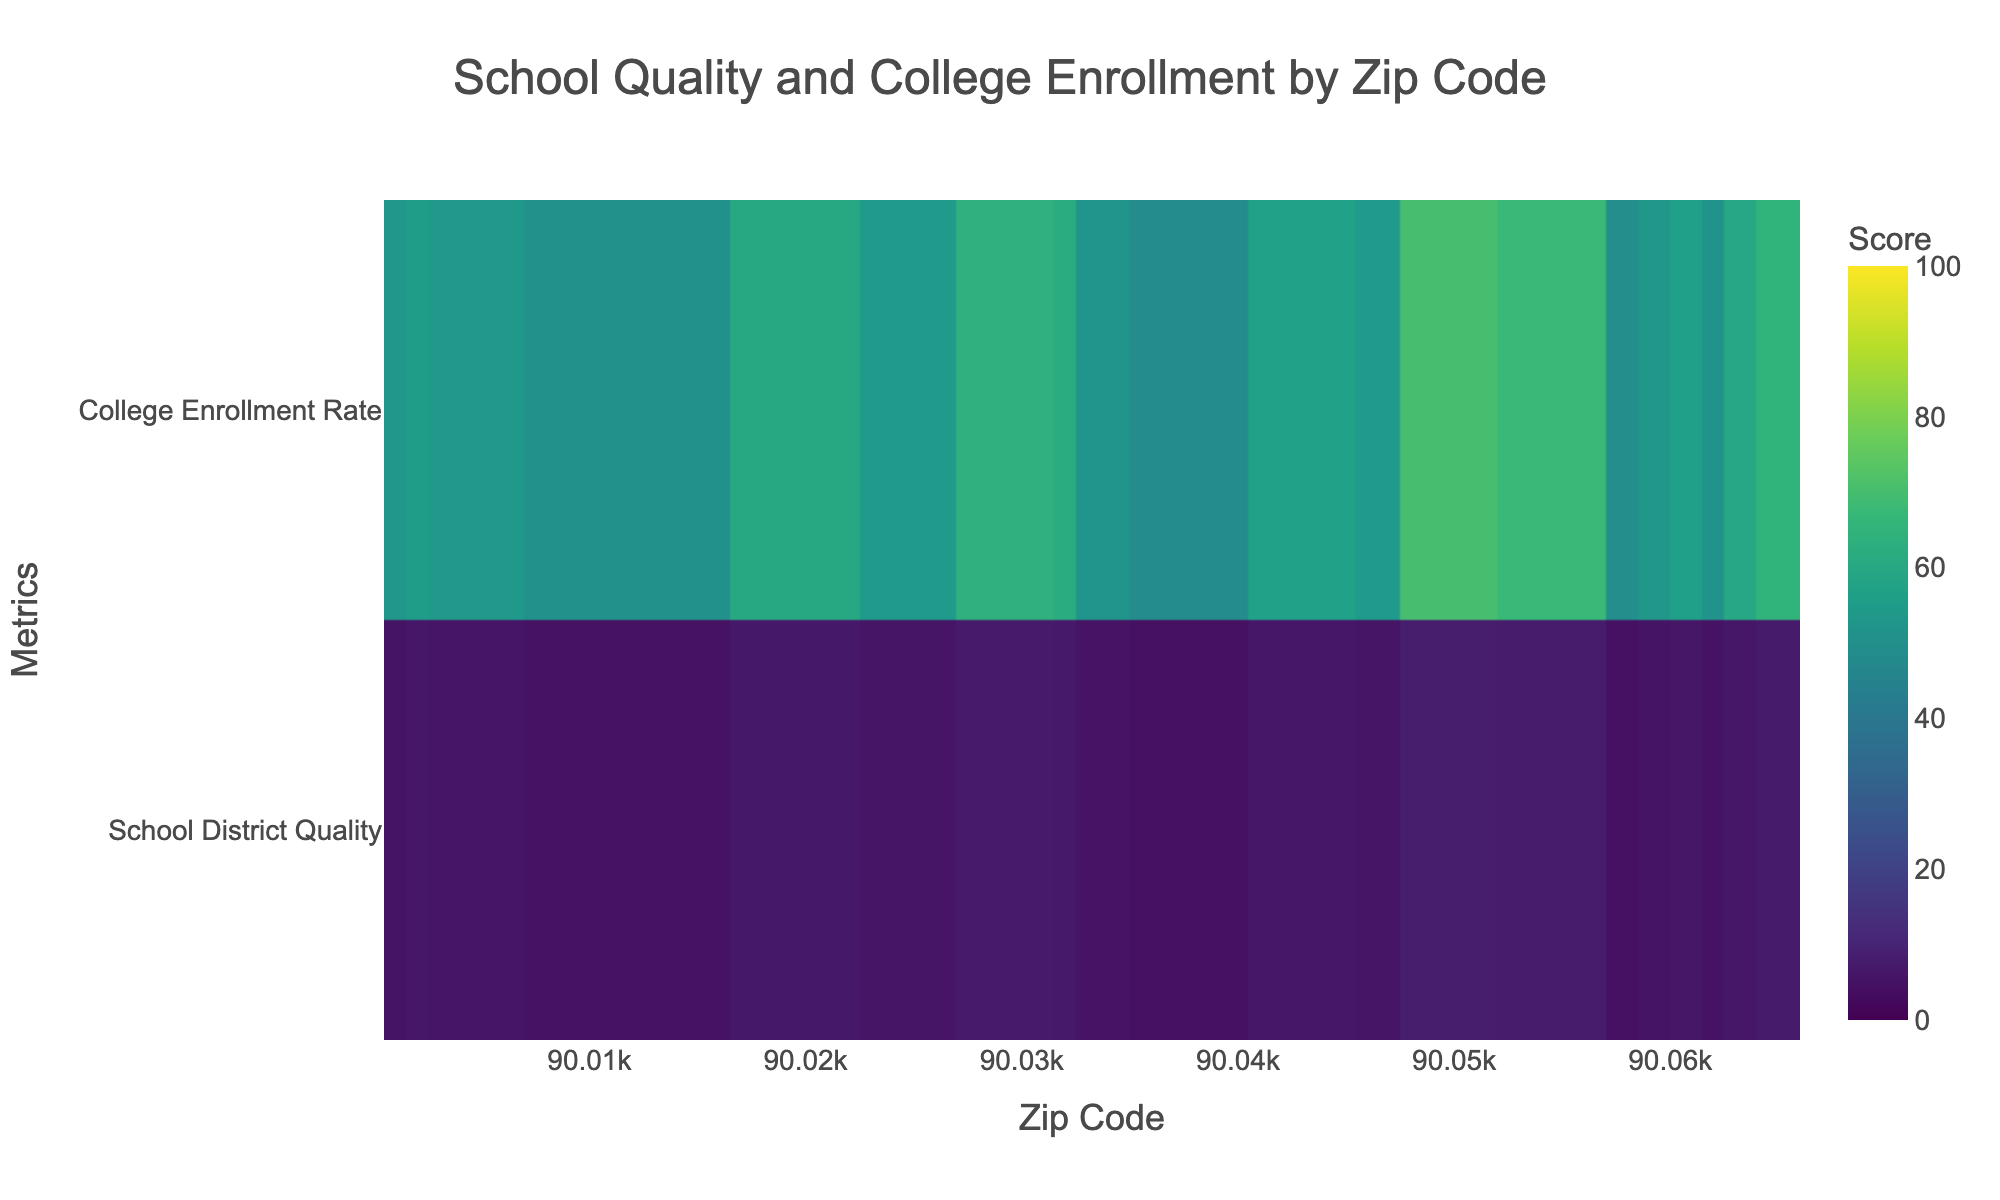What's the title of the figure? The title is located at the top of the figure. It is clearly mentioned and serves as an introduction to what the heatmap represents.
Answer: School Quality and College Enrollment by Zip Code What are the variables displayed on the Y-axis? The Y-axis typically shows the categories or metrics being measured in a heatmap. In this case, the Y-axis includes labels for the two metrics.
Answer: School District Quality, College Enrollment Rate Which zip code has the highest school district quality score? Observe the data values associated with the zip codes. Identify the maximum value in the row corresponding to the School District Quality.
Answer: 90048 What is the color scale used in the heatmap? The color scale represents the range of values visually. The heatmap uses a certain color pattern to differentiate the scores.
Answer: Viridis Which zip code shows the lowest college enrollment rate? Look at the 'College Enrollment Rate' row and identify the minimum value and its associated zip code.
Answer: 90037 Do higher school district quality scores correlate with higher college enrollment rates? To interpret the overall relationship, examine whether the zip codes with higher school scores tend to have higher college rates and vice versa.
Answer: Generally yes How do the school district quality score and college enrollment rate for zip code 90033 compare? Check the values for zip code 90033 in the rows for both metrics.
Answer: School Score: 5.1, College Rate: 51.9 